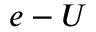<formula> <loc_0><loc_0><loc_500><loc_500>e - U</formula> 